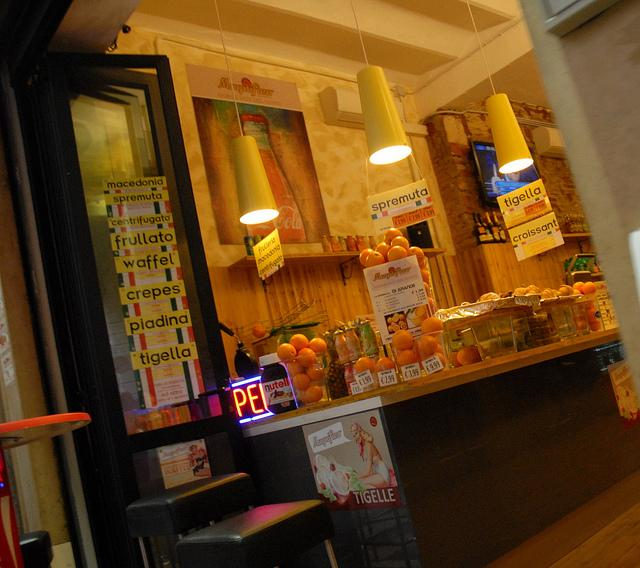What do people do here?

Choices:
A) swim
B) eat
C) gamble
D) drive eat 